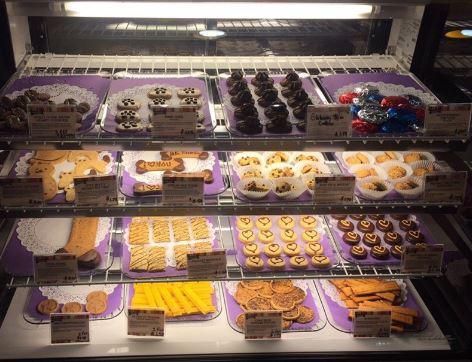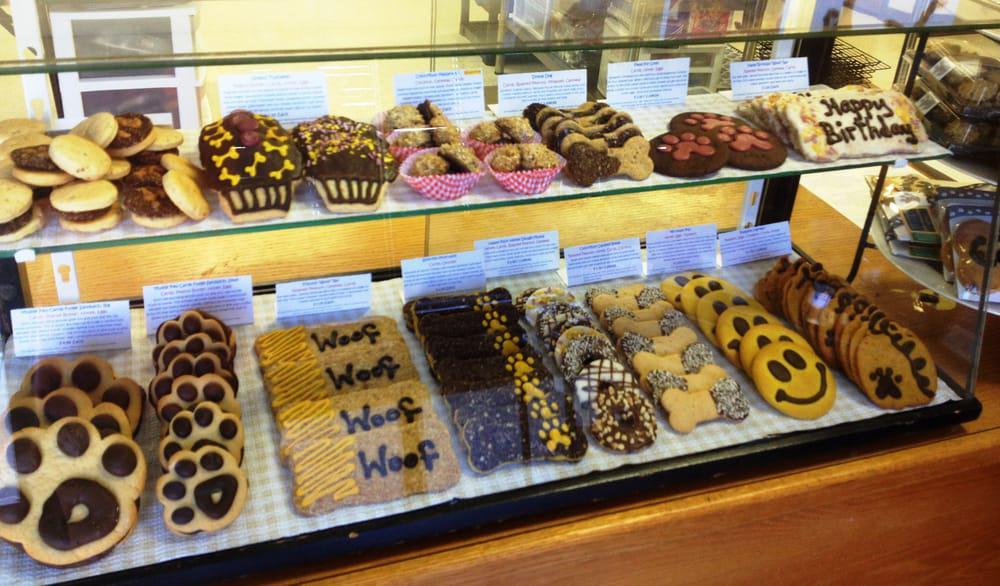The first image is the image on the left, the second image is the image on the right. Considering the images on both sides, is "The right image shows a glass display case containing white trays of glazed and coated ball-shaped treats with stick handles." valid? Answer yes or no. No. The first image is the image on the left, the second image is the image on the right. Assess this claim about the two images: "One of the cases has four shelves displaying different baked goods.". Correct or not? Answer yes or no. Yes. 